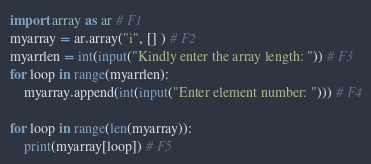Convert code to text. <code><loc_0><loc_0><loc_500><loc_500><_Python_>import array as ar # F1
myarray = ar.array("i", [] ) # F2
myarrlen = int(input("Kindly enter the array length: ")) # F3
for loop in range(myarrlen):
    myarray.append(int(input("Enter element number: "))) # F4

for loop in range(len(myarray)):
    print(myarray[loop]) # F5
</code> 